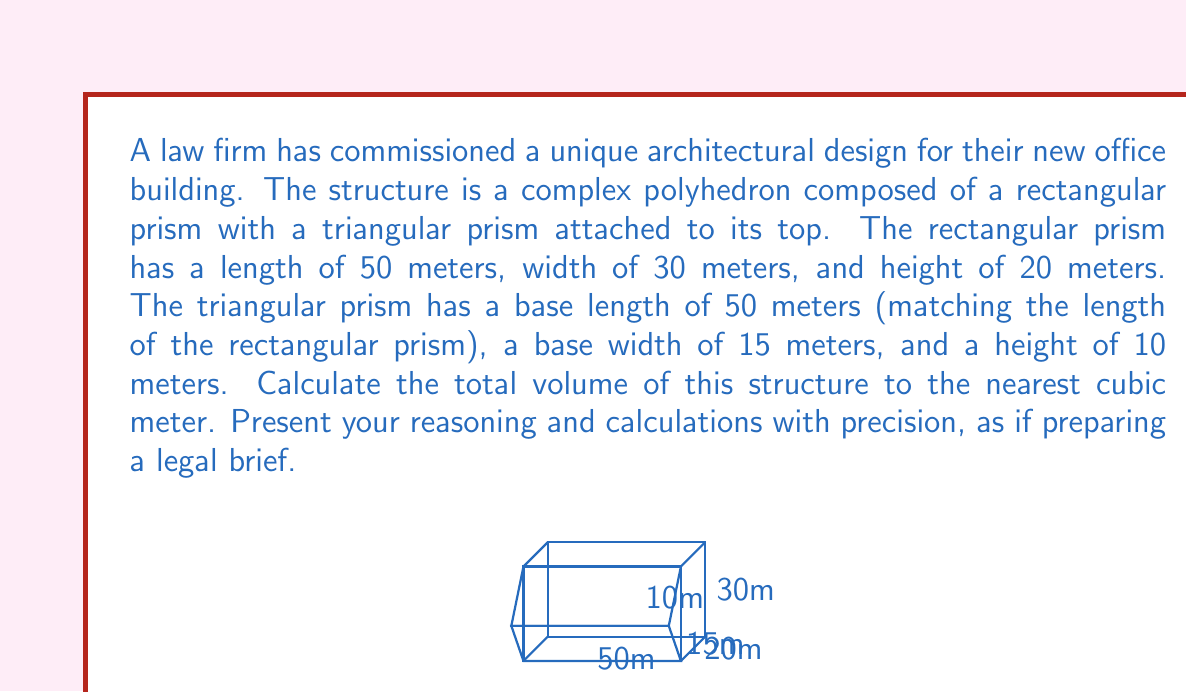Can you answer this question? To calculate the total volume of this complex polyhedron, we need to determine the volumes of its constituent parts and sum them up. Let's approach this step-by-step:

1. Volume of the rectangular prism:
   $$V_{rectangular} = length \times width \times height$$
   $$V_{rectangular} = 50 \text{ m} \times 30 \text{ m} \times 20 \text{ m} = 30,000 \text{ m}^3$$

2. Volume of the triangular prism:
   The volume of a triangular prism is given by the area of its triangular base multiplied by its length.
   
   Area of the triangular base:
   $$A_{base} = \frac{1}{2} \times base \times height$$
   $$A_{base} = \frac{1}{2} \times 15 \text{ m} \times 10 \text{ m} = 75 \text{ m}^2$$
   
   Volume of the triangular prism:
   $$V_{triangular} = A_{base} \times length$$
   $$V_{triangular} = 75 \text{ m}^2 \times 50 \text{ m} = 3,750 \text{ m}^3$$

3. Total volume:
   $$V_{total} = V_{rectangular} + V_{triangular}$$
   $$V_{total} = 30,000 \text{ m}^3 + 3,750 \text{ m}^3 = 33,750 \text{ m}^3$$

Therefore, the total volume of the complex polyhedron is 33,750 cubic meters.
Answer: 33,750 cubic meters 